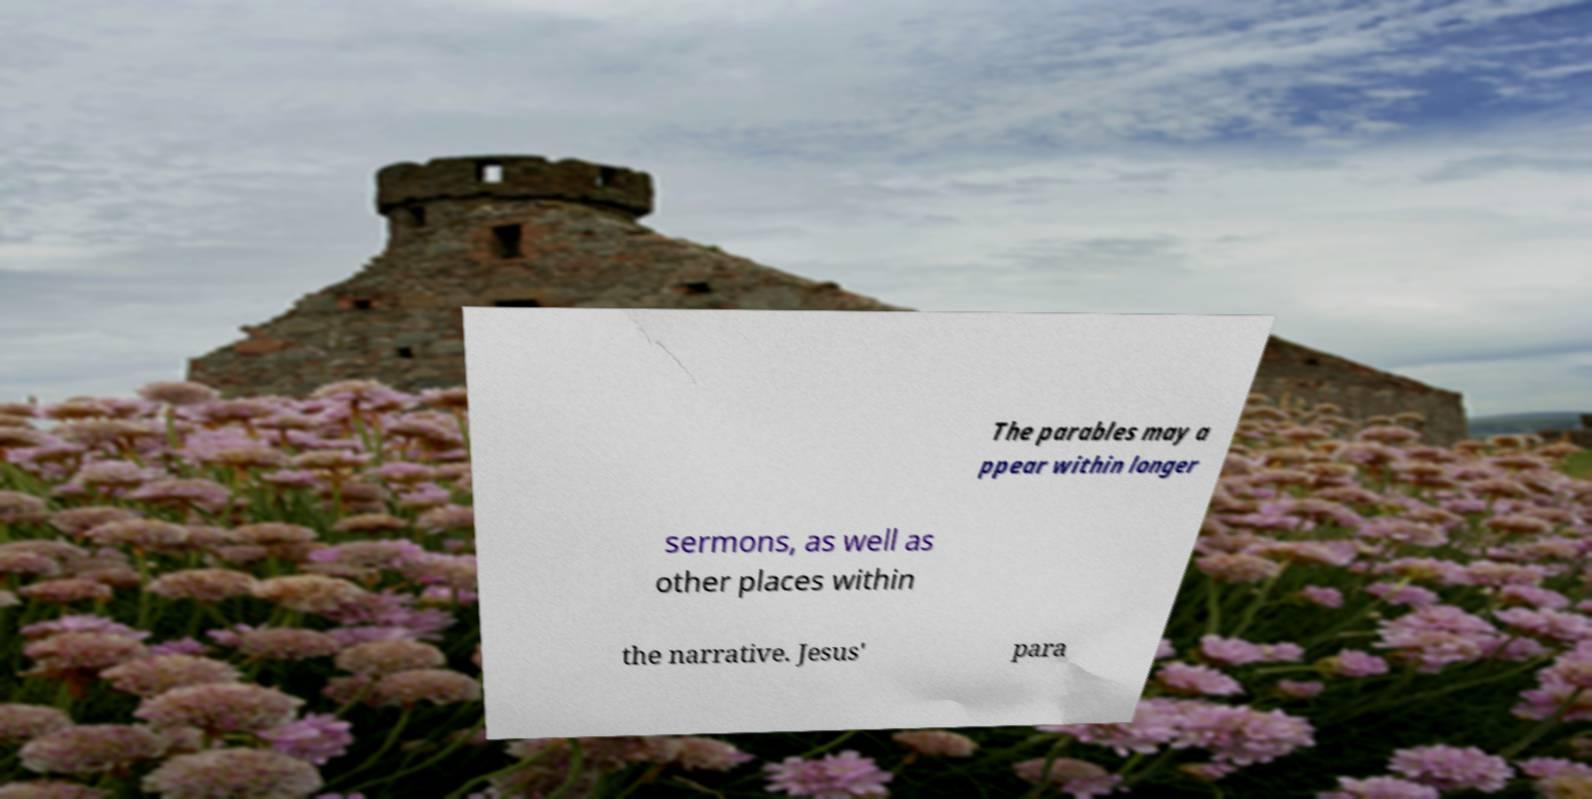For documentation purposes, I need the text within this image transcribed. Could you provide that? The parables may a ppear within longer sermons, as well as other places within the narrative. Jesus' para 